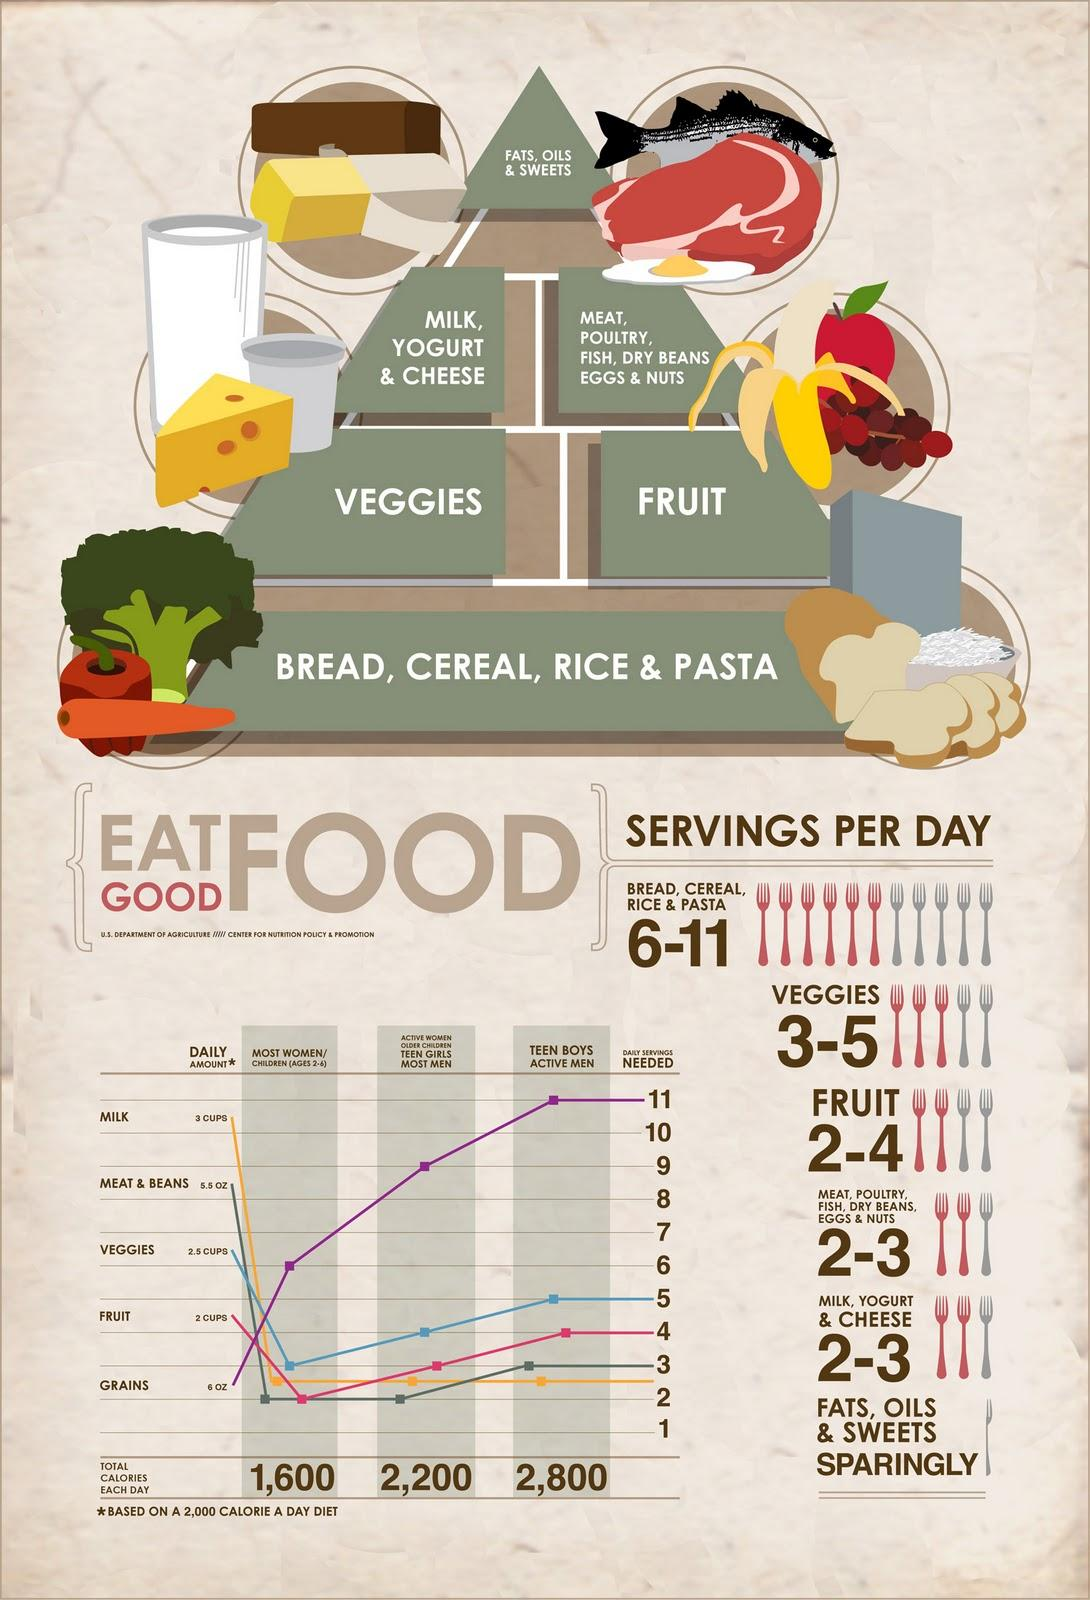Outline some significant characteristics in this image. The topmost layer of the food pyramid is composed of fats, oils, and sweets. Based on the food pyramid, it is recommended that an individual should prioritize consuming carbohydrates as the primary source of nutrition in their diet. It is recommended that all individuals of all genders and age groups consume milk in equal servings every day for optimal health. According to the recommended daily intake of vegetables, women and children aged 2-6 years old should consume three daily servings of vegetables to meet their nutritional needs. Most women and men require two daily servings of meats and beans for optimal health. 